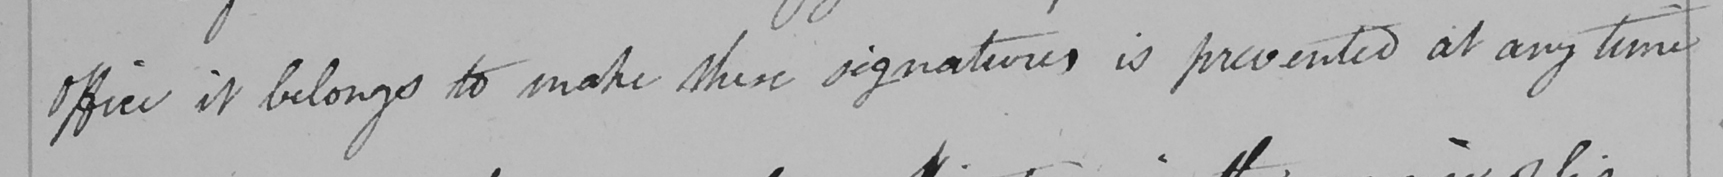What text is written in this handwritten line? Office it belongs to make these signatures is prevented at any time 